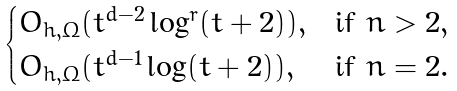Convert formula to latex. <formula><loc_0><loc_0><loc_500><loc_500>\begin{cases} O _ { h , \Omega } ( t ^ { d - 2 } \log ^ { r } ( t + 2 ) ) , & \text {if } n > 2 , \\ O _ { h , \Omega } ( t ^ { d - 1 } \log ( t + 2 ) ) , & \text {if } n = 2 . \end{cases}</formula> 